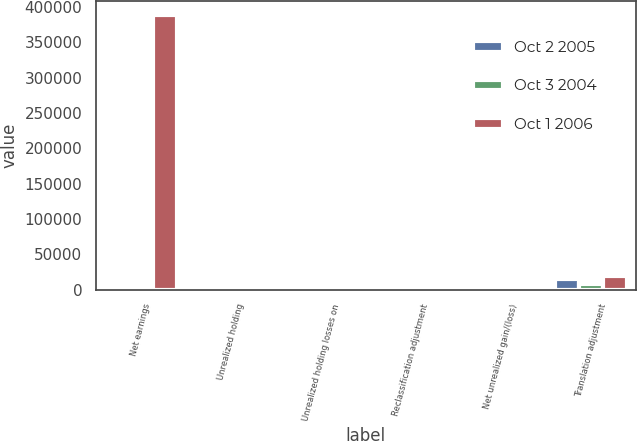<chart> <loc_0><loc_0><loc_500><loc_500><stacked_bar_chart><ecel><fcel>Net earnings<fcel>Unrealized holding<fcel>Unrealized holding losses on<fcel>Reclassification adjustment<fcel>Net unrealized gain/(loss)<fcel>Translation adjustment<nl><fcel>Oct 2 2005<fcel>1965.5<fcel>35<fcel>2803<fcel>4138<fcel>1767<fcel>14592<nl><fcel>Oct 3 2004<fcel>1965.5<fcel>1037<fcel>3861<fcel>3302<fcel>350<fcel>8677<nl><fcel>Oct 1 2006<fcel>388880<fcel>558<fcel>4769<fcel>1200<fcel>4925<fcel>19892<nl></chart> 